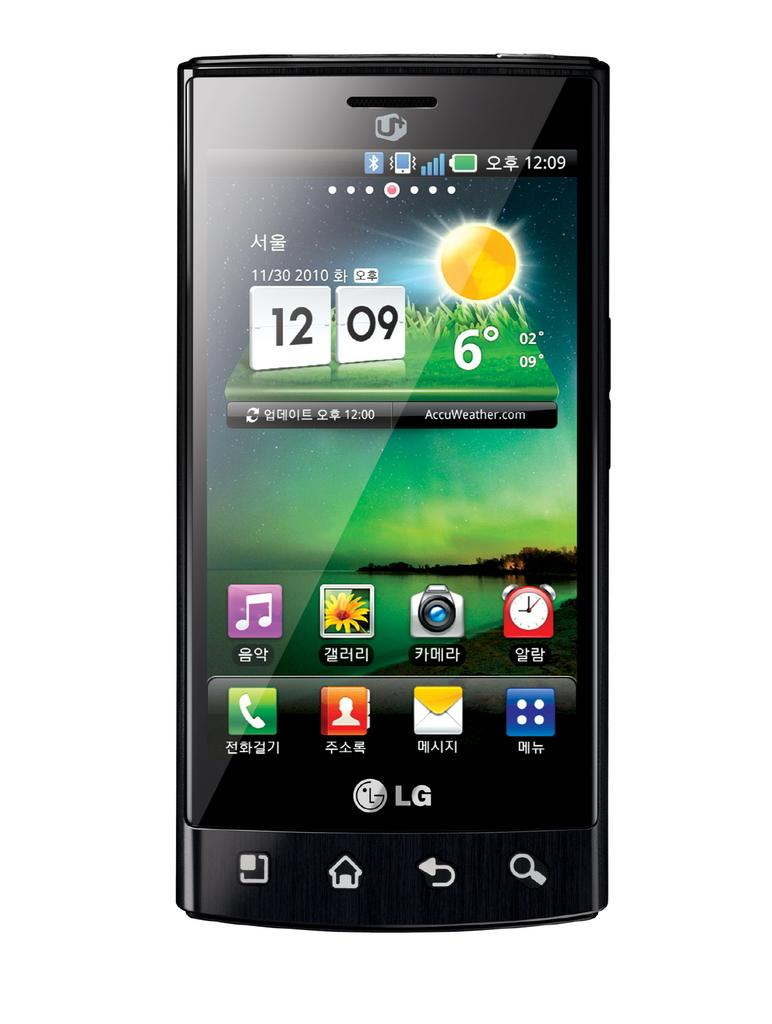Provide a one-sentence caption for the provided image. The front os a LG mobile phone with several icons and the time 12:09 displayed. 